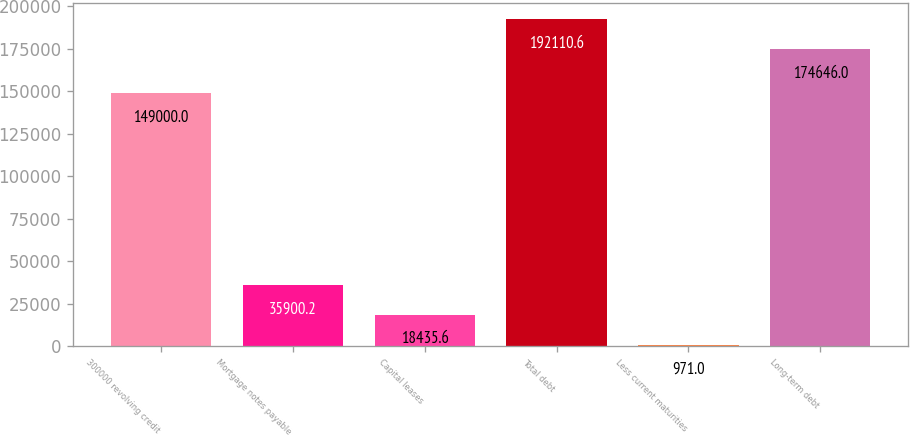<chart> <loc_0><loc_0><loc_500><loc_500><bar_chart><fcel>300000 revolving credit<fcel>Mortgage notes payable<fcel>Capital leases<fcel>Total debt<fcel>Less current maturities<fcel>Long-term debt<nl><fcel>149000<fcel>35900.2<fcel>18435.6<fcel>192111<fcel>971<fcel>174646<nl></chart> 